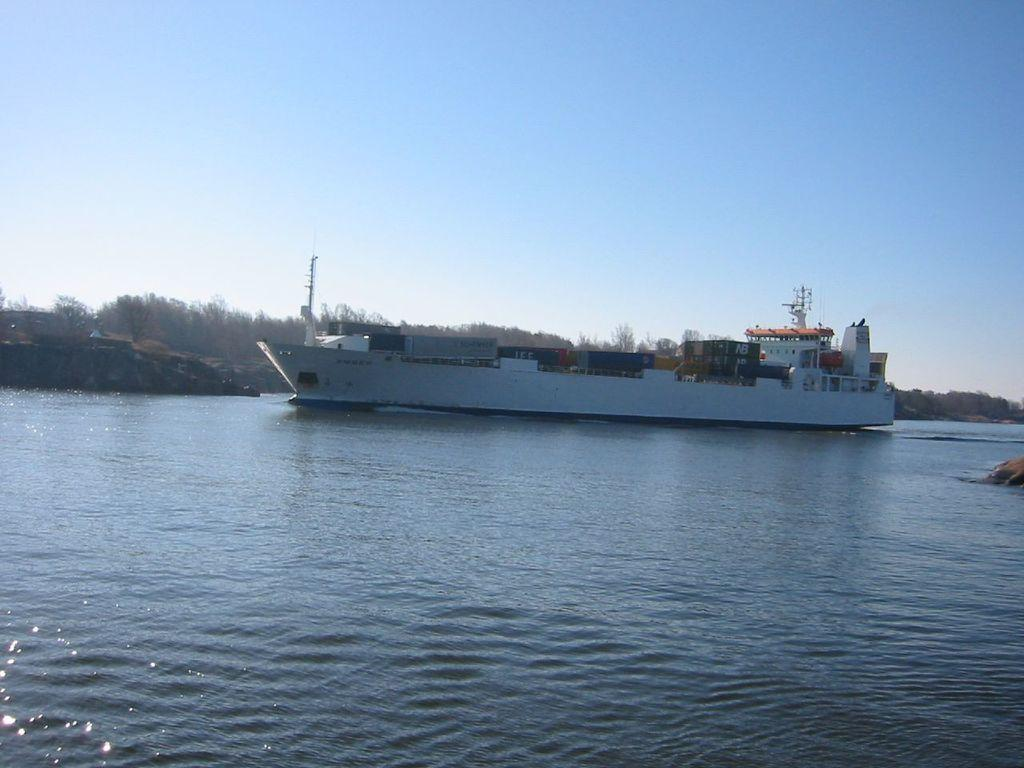What is the main subject of the image? The main subject of the image is a ship. Where is the ship located in the image? The ship is on the water in the image. What other natural elements can be seen in the image? There are rocks and trees visible in the image. What is visible in the background of the image? The sky is visible in the image, and clouds are present in the sky. What type of houses can be seen in the image? There are no houses present in the image; it features a ship on the water with rocks, trees, and a sky with clouds. What letters are visible on the ship in the image? There are no letters visible on the ship in the image. 